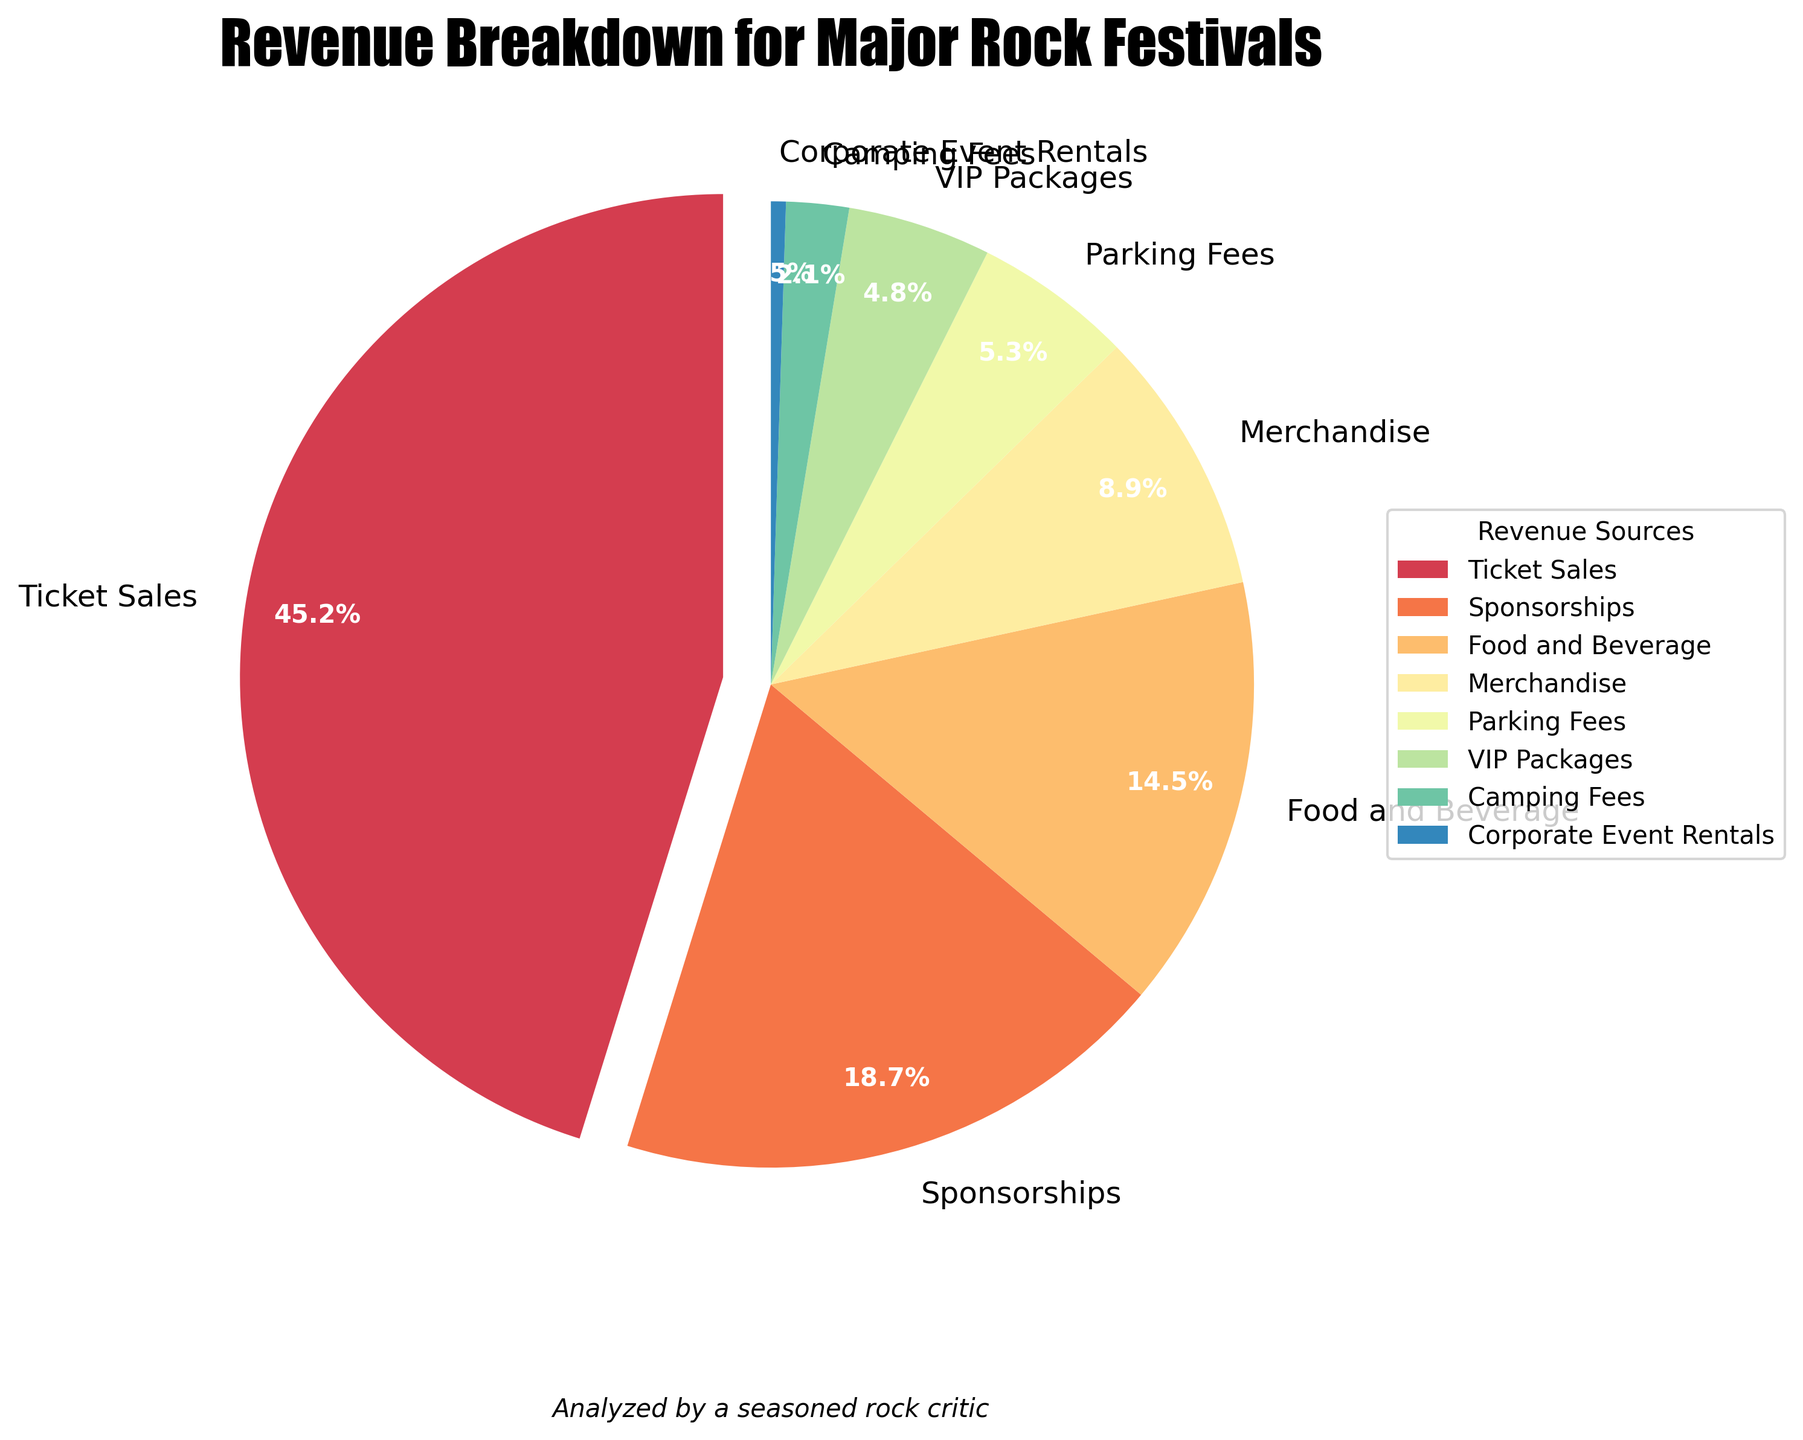What is the largest revenue source for major rock music festivals? The largest percentage in the pie chart is from "Ticket Sales," which has a 45.2% share.
Answer: Ticket Sales Which revenue source contributes more: Parking Fees or Camping Fees? Parking Fees are represented with 5.3%, while Camping Fees contribute 2.1%. Parking Fees contribute more.
Answer: Parking Fees What is the combined percentage of revenue from Food and Beverage and Merchandise? Food and Beverage contributes 14.5% and Merchandise accounts for 8.9%. Combined, it is 14.5% + 8.9% = 23.4%.
Answer: 23.4% How much more does Sponsorships contribute to the revenue compared to VIP Packages? Sponsorships contribute 18.7% and VIP Packages contribute 4.8%. The difference is 18.7% - 4.8% = 13.9%.
Answer: 13.9% Which revenue source has the smallest impact, and what is its percentage? The slice representing Corporate Event Rentals is the smallest, with a percentage of 0.5%.
Answer: Corporate Event Rentals, 0.5% What is the difference in revenue contribution between Food and Beverage and Ticket Sales? Ticket Sales contribute 45.2%, and Food and Beverage contribute 14.5%. The difference is 45.2% - 14.5% = 30.7%.
Answer: 30.7% Between Merchandise and VIP Packages, which contributes more, and by what percentage? Merchandise contributes 8.9%, whereas VIP Packages contribute 4.8%. Merchandise contributes more by 8.9% - 4.8% = 4.1%.
Answer: Merchandise, 4.1% Estimate the visual angle size difference between the largest and smallest slices of the pie chart in degrees. A pie chart totals 360 degrees. The largest slice (Ticket Sales) is 45.2% of the chart: 45.2% of 360 = 0.452 * 360 = 162.72 degrees. The smallest slice (Corporate Event Rentals) is 0.5% of the chart: 0.5% of 360 = 0.005 * 360 = 1.8 degrees. The difference is 162.72 - 1.8 = 160.92 degrees.
Answer: 160.92 degrees 